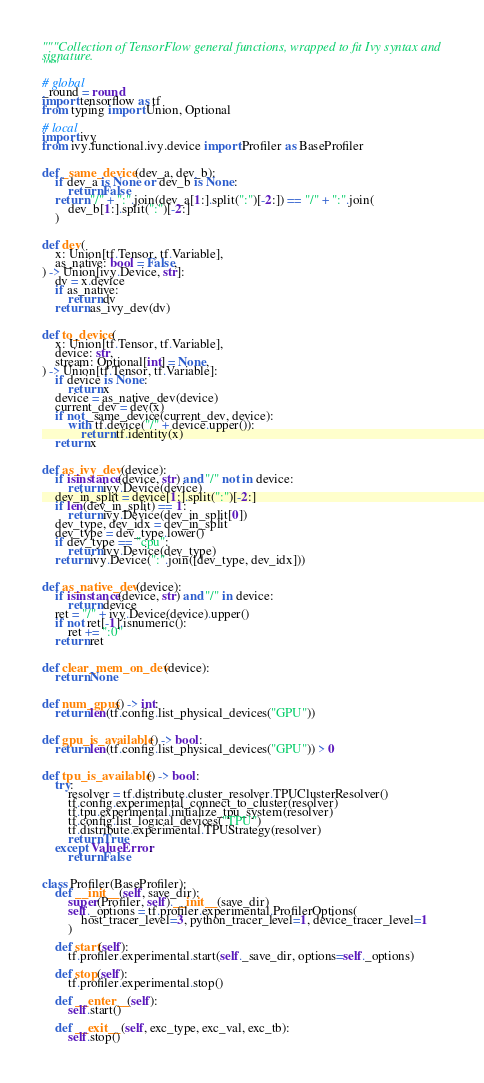<code> <loc_0><loc_0><loc_500><loc_500><_Python_>"""Collection of TensorFlow general functions, wrapped to fit Ivy syntax and
signature.
"""

# global
_round = round
import tensorflow as tf
from typing import Union, Optional

# local
import ivy
from ivy.functional.ivy.device import Profiler as BaseProfiler


def _same_device(dev_a, dev_b):
    if dev_a is None or dev_b is None:
        return False
    return "/" + ":".join(dev_a[1:].split(":")[-2:]) == "/" + ":".join(
        dev_b[1:].split(":")[-2:]
    )


def dev(
    x: Union[tf.Tensor, tf.Variable],
    as_native: bool = False,
) -> Union[ivy.Device, str]:
    dv = x.device
    if as_native:
        return dv
    return as_ivy_dev(dv)


def to_device(
    x: Union[tf.Tensor, tf.Variable],
    device: str,
    stream: Optional[int] = None,
) -> Union[tf.Tensor, tf.Variable]:
    if device is None:
        return x
    device = as_native_dev(device)
    current_dev = dev(x)
    if not _same_device(current_dev, device):
        with tf.device("/" + device.upper()):
            return tf.identity(x)
    return x


def as_ivy_dev(device):
    if isinstance(device, str) and "/" not in device:
        return ivy.Device(device)
    dev_in_split = device[1:].split(":")[-2:]
    if len(dev_in_split) == 1:
        return ivy.Device(dev_in_split[0])
    dev_type, dev_idx = dev_in_split
    dev_type = dev_type.lower()
    if dev_type == "cpu":
        return ivy.Device(dev_type)
    return ivy.Device(":".join([dev_type, dev_idx]))


def as_native_dev(device):
    if isinstance(device, str) and "/" in device:
        return device
    ret = "/" + ivy.Device(device).upper()
    if not ret[-1].isnumeric():
        ret += ":0"
    return ret


def clear_mem_on_dev(device):
    return None


def num_gpus() -> int:
    return len(tf.config.list_physical_devices("GPU"))


def gpu_is_available() -> bool:
    return len(tf.config.list_physical_devices("GPU")) > 0


def tpu_is_available() -> bool:
    try:
        resolver = tf.distribute.cluster_resolver.TPUClusterResolver()
        tf.config.experimental_connect_to_cluster(resolver)
        tf.tpu.experimental.initialize_tpu_system(resolver)
        tf.config.list_logical_devices("TPU")
        tf.distribute.experimental.TPUStrategy(resolver)
        return True
    except ValueError:
        return False


class Profiler(BaseProfiler):
    def __init__(self, save_dir):
        super(Profiler, self).__init__(save_dir)
        self._options = tf.profiler.experimental.ProfilerOptions(
            host_tracer_level=3, python_tracer_level=1, device_tracer_level=1
        )

    def start(self):
        tf.profiler.experimental.start(self._save_dir, options=self._options)

    def stop(self):
        tf.profiler.experimental.stop()

    def __enter__(self):
        self.start()

    def __exit__(self, exc_type, exc_val, exc_tb):
        self.stop()
</code> 